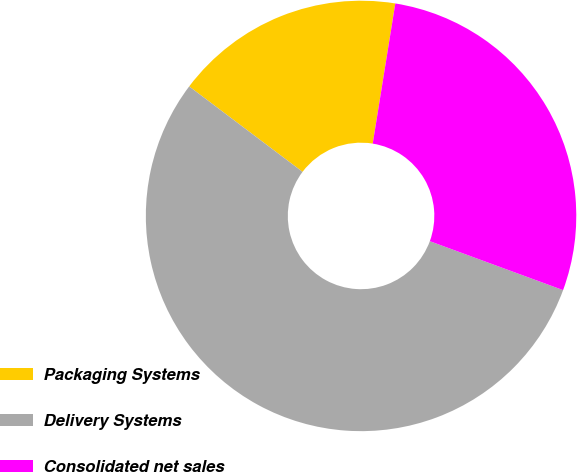Convert chart to OTSL. <chart><loc_0><loc_0><loc_500><loc_500><pie_chart><fcel>Packaging Systems<fcel>Delivery Systems<fcel>Consolidated net sales<nl><fcel>17.27%<fcel>54.68%<fcel>28.06%<nl></chart> 